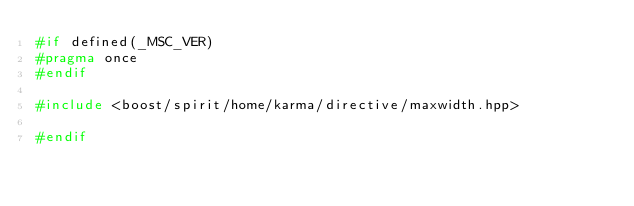<code> <loc_0><loc_0><loc_500><loc_500><_C++_>#if defined(_MSC_VER)
#pragma once
#endif

#include <boost/spirit/home/karma/directive/maxwidth.hpp>

#endif
</code> 